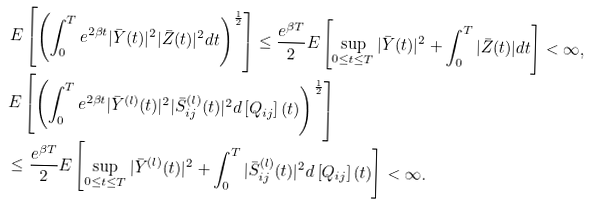<formula> <loc_0><loc_0><loc_500><loc_500>& E \left [ \left ( \int _ { 0 } ^ { T } e ^ { 2 \beta t } | \bar { Y } ( t ) | ^ { 2 } | \bar { Z } ( t ) | ^ { 2 } d t \right ) ^ { \frac { 1 } { 2 } } \right ] \leq \frac { e ^ { \beta T } } { 2 } E \left [ \sup _ { 0 \leq t \leq T } | \bar { Y } ( t ) | ^ { 2 } + \int _ { 0 } ^ { T } | \bar { Z } ( t ) | d t \right ] < \infty , \\ & E \left [ \left ( \int _ { 0 } ^ { T } e ^ { 2 \beta t } | \bar { Y } ^ { ( l ) } ( t ) | ^ { 2 } | \bar { S } _ { i j } ^ { ( l ) } ( t ) | ^ { 2 } d \left [ Q _ { i j } \right ] ( t ) \right ) ^ { \frac { 1 } { 2 } } \right ] \\ & \leq \frac { e ^ { \beta T } } { 2 } E \left [ \sup _ { 0 \leq t \leq T } | \bar { Y } ^ { ( l ) } ( t ) | ^ { 2 } + \int _ { 0 } ^ { T } | \bar { S } ^ { ( l ) } _ { i j } ( t ) | ^ { 2 } d \left [ Q _ { i j } \right ] ( t ) \right ] < \infty .</formula> 